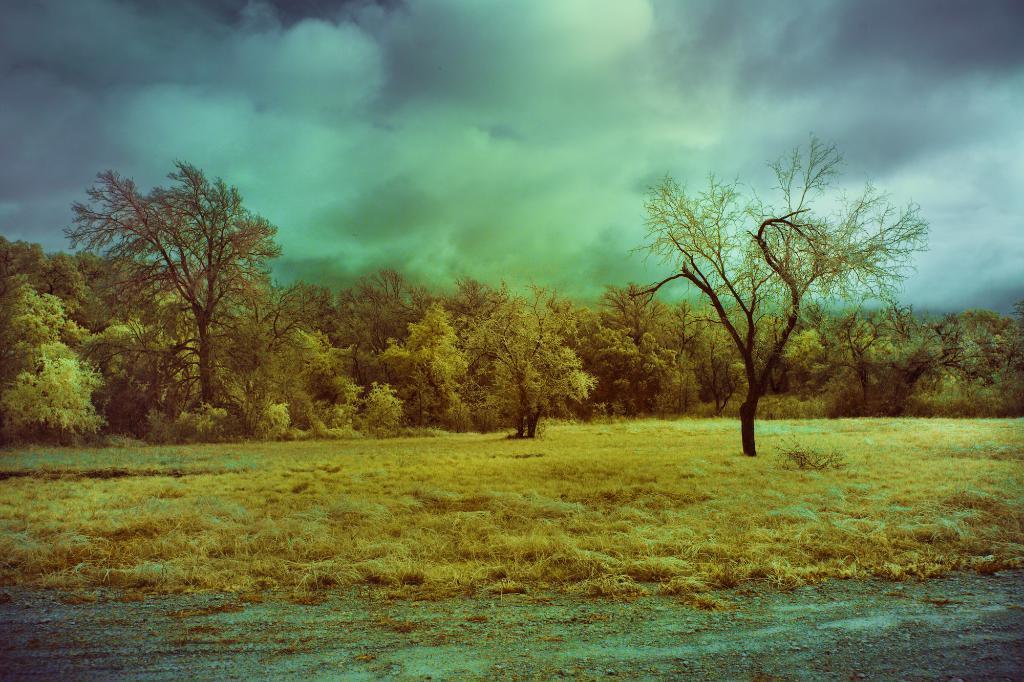In one or two sentences, can you explain what this image depicts? These are the trees with the branches and leaves. This looks like a grass. I can see the clouds in the sky. 